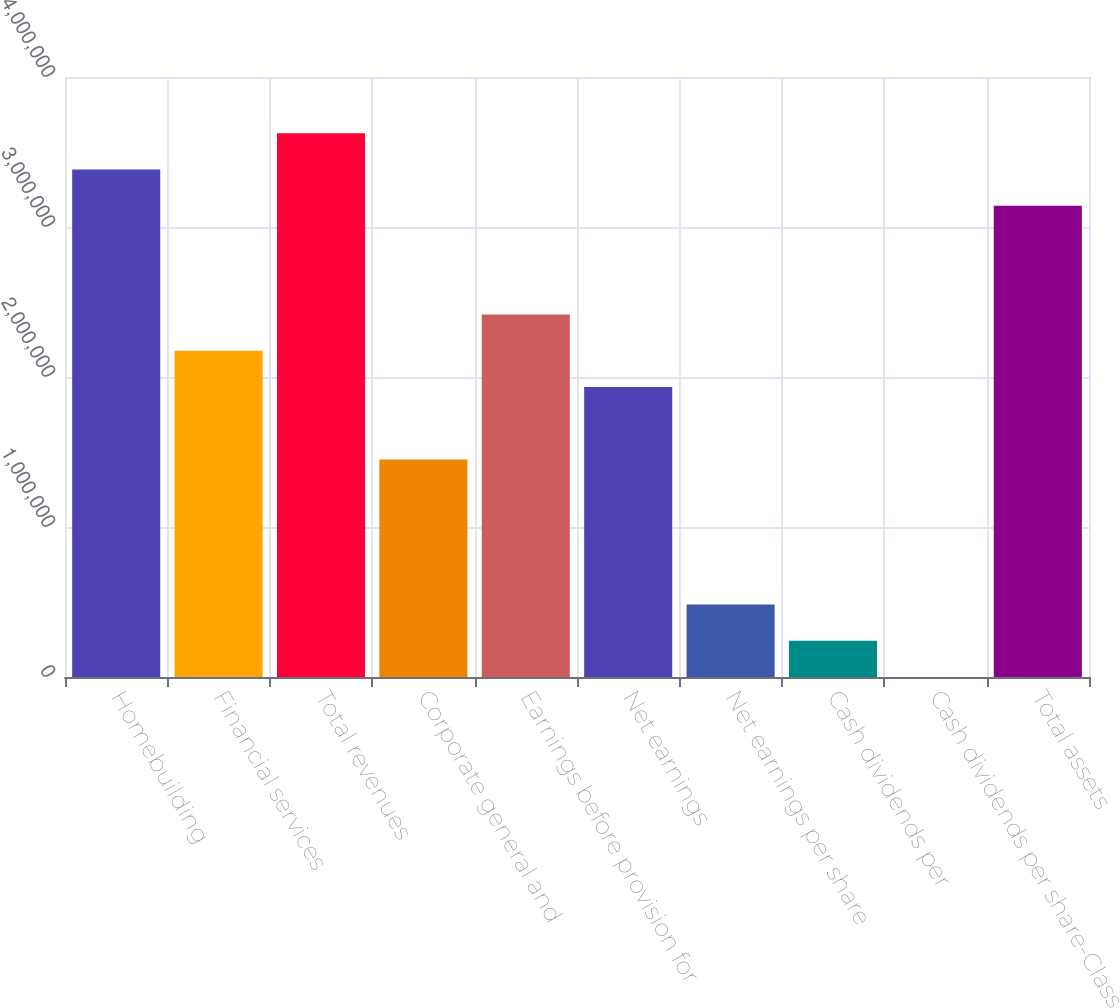<chart> <loc_0><loc_0><loc_500><loc_500><bar_chart><fcel>Homebuilding<fcel>Financial services<fcel>Total revenues<fcel>Corporate general and<fcel>Earnings before provision for<fcel>Net earnings<fcel>Net earnings per share<fcel>Cash dividends per<fcel>Cash dividends per share-Class<fcel>Total assets<nl><fcel>3.38361e+06<fcel>2.17518e+06<fcel>3.6253e+06<fcel>1.45012e+06<fcel>2.41687e+06<fcel>1.93349e+06<fcel>483373<fcel>241687<fcel>0.04<fcel>3.14192e+06<nl></chart> 